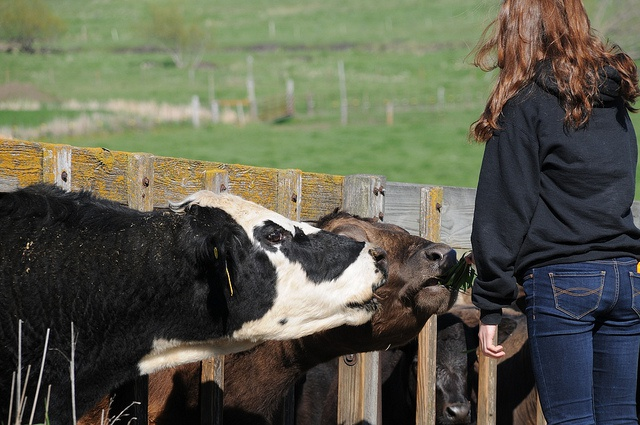Describe the objects in this image and their specific colors. I can see cow in olive, black, lightgray, gray, and darkgray tones, people in olive, black, darkblue, and gray tones, cow in olive, black, maroon, and gray tones, and cow in olive, black, and gray tones in this image. 